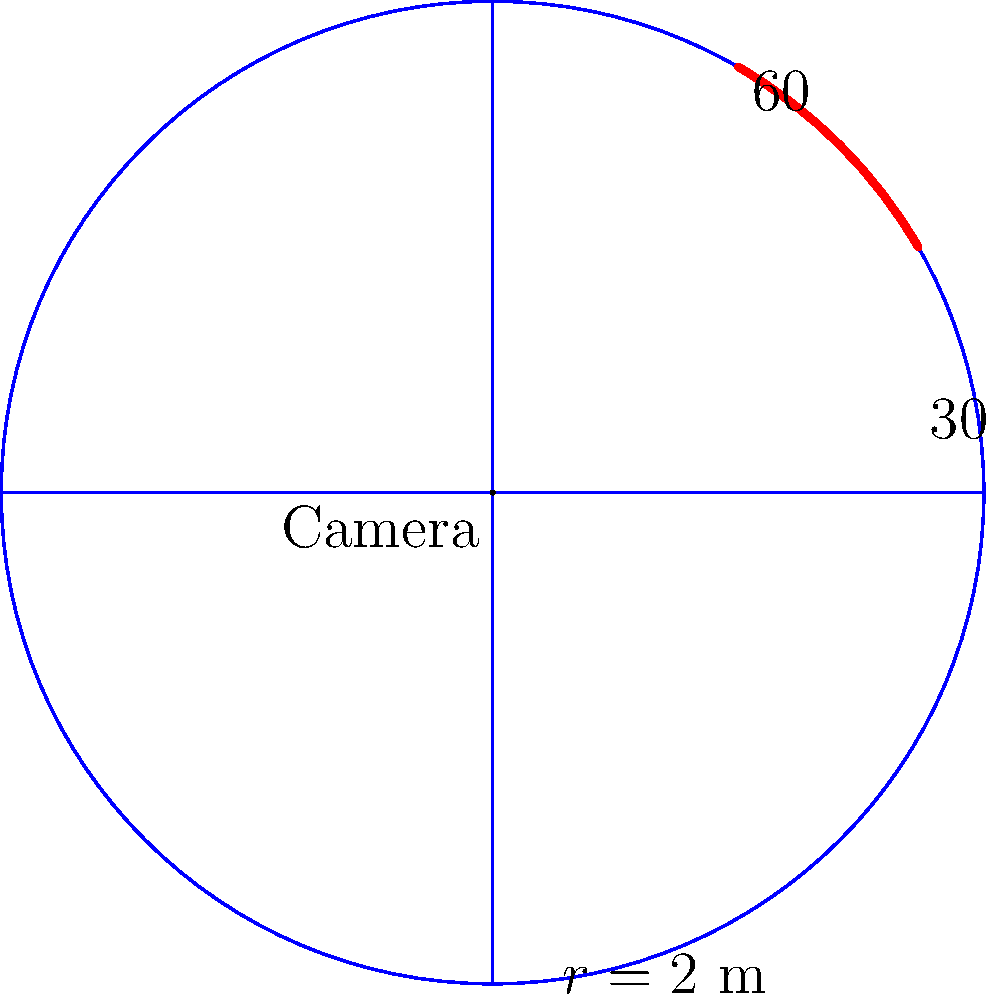A rotating security camera is installed in your office to monitor a circular area. The camera's range is 2 meters, and it rotates between 30° and 60° (measured counterclockwise from the positive x-axis). What is the area of the sector covered by the camera in square meters? Express your answer in terms of π. To find the area of the sector covered by the rotating camera, we'll follow these steps:

1) The area of a sector is given by the formula:
   $A = \frac{1}{2}r^2\theta$
   where $r$ is the radius and $\theta$ is the central angle in radians.

2) We're given:
   - Radius $r = 2$ meters
   - The camera rotates from 30° to 60°

3) First, we need to find the central angle $\theta$ in radians:
   $\theta = 60° - 30° = 30°$
   To convert to radians: $30° \times \frac{\pi}{180°} = \frac{\pi}{6}$ radians

4) Now we can plug these values into our formula:
   $A = \frac{1}{2}r^2\theta$
   $A = \frac{1}{2}(2^2)(\frac{\pi}{6})$
   $A = \frac{1}{2}(4)(\frac{\pi}{6})$
   $A = \frac{4\pi}{12}$
   $A = \frac{\pi}{3}$

Therefore, the area of the sector covered by the camera is $\frac{\pi}{3}$ square meters.
Answer: $\frac{\pi}{3}$ sq m 